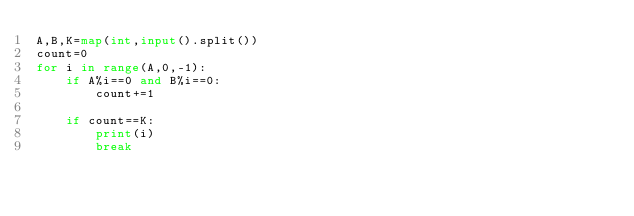Convert code to text. <code><loc_0><loc_0><loc_500><loc_500><_Python_>A,B,K=map(int,input().split())
count=0
for i in range(A,0,-1):
    if A%i==0 and B%i==0:
        count+=1

    if count==K:
        print(i)
        break</code> 